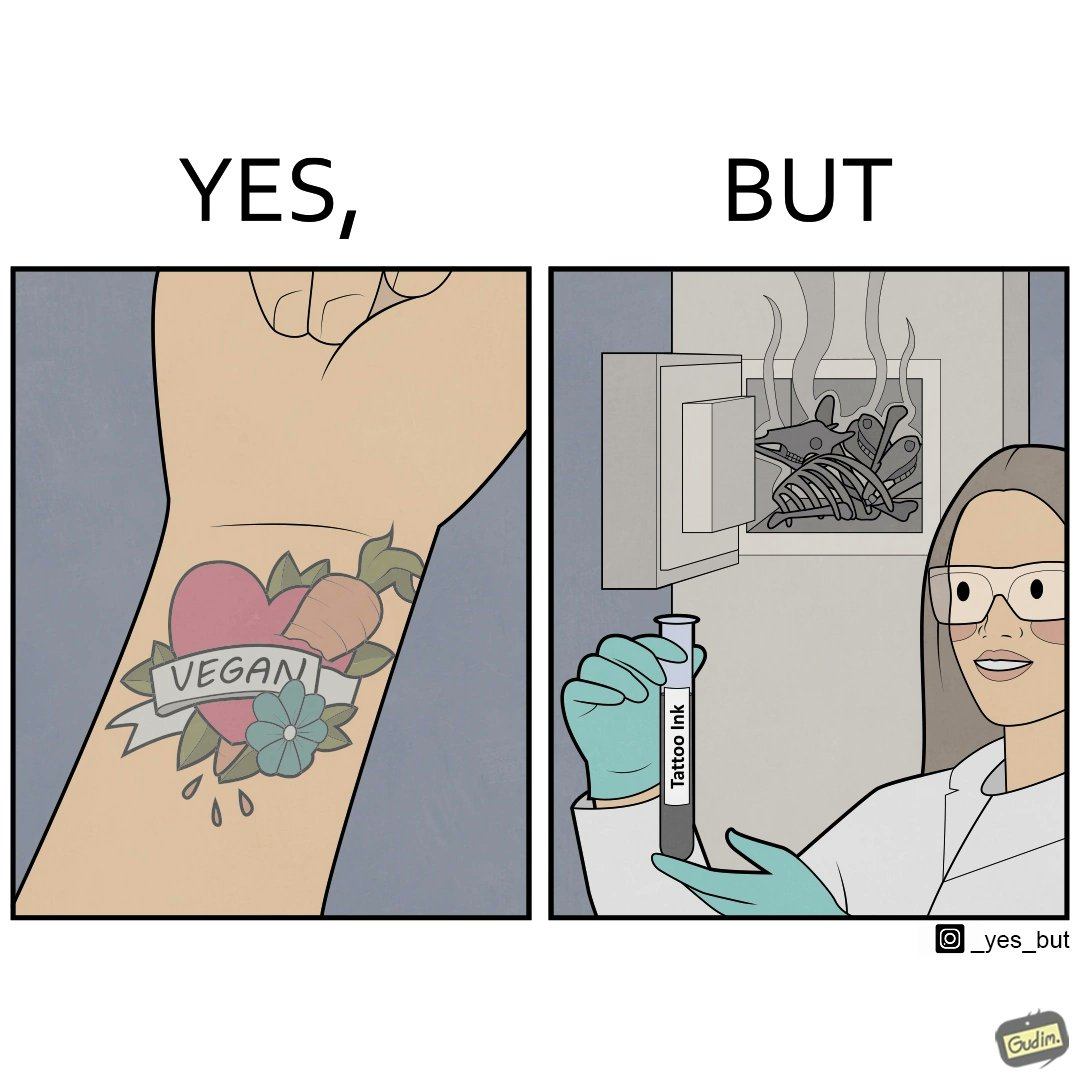Why is this image considered satirical? The irony in this video is that people try to promote and embrace veganism end up using products that are not animal-free. 